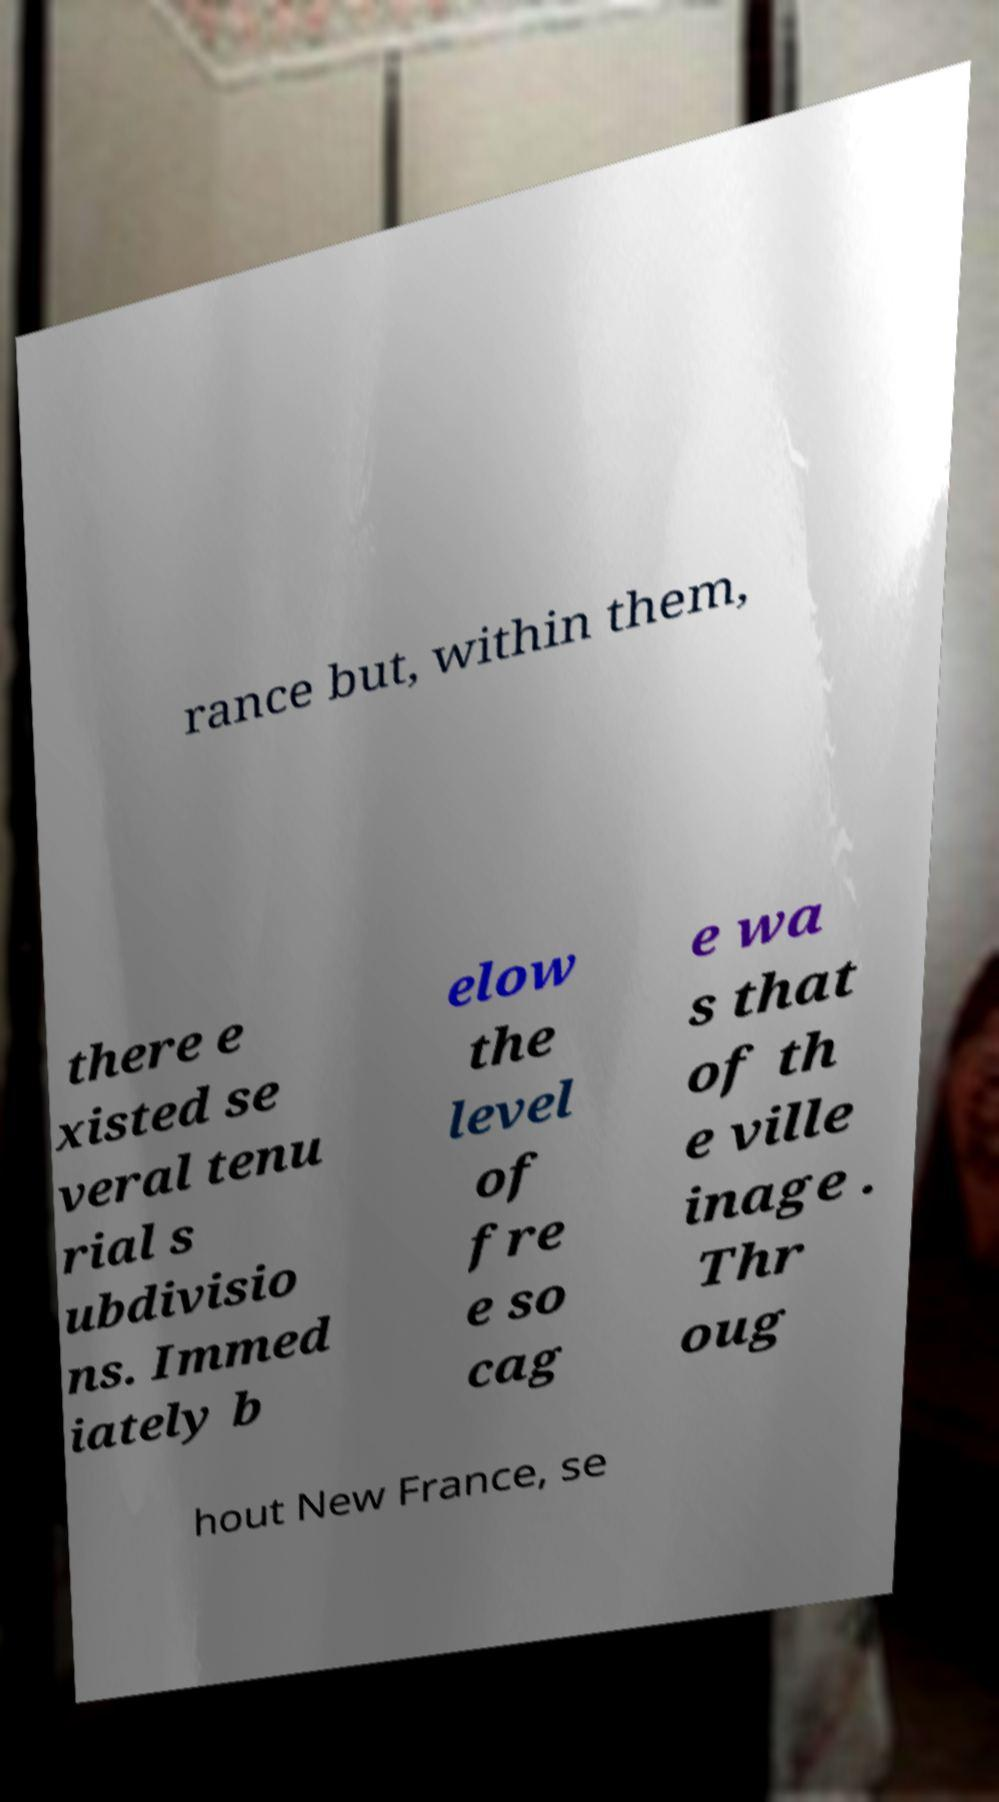There's text embedded in this image that I need extracted. Can you transcribe it verbatim? rance but, within them, there e xisted se veral tenu rial s ubdivisio ns. Immed iately b elow the level of fre e so cag e wa s that of th e ville inage . Thr oug hout New France, se 